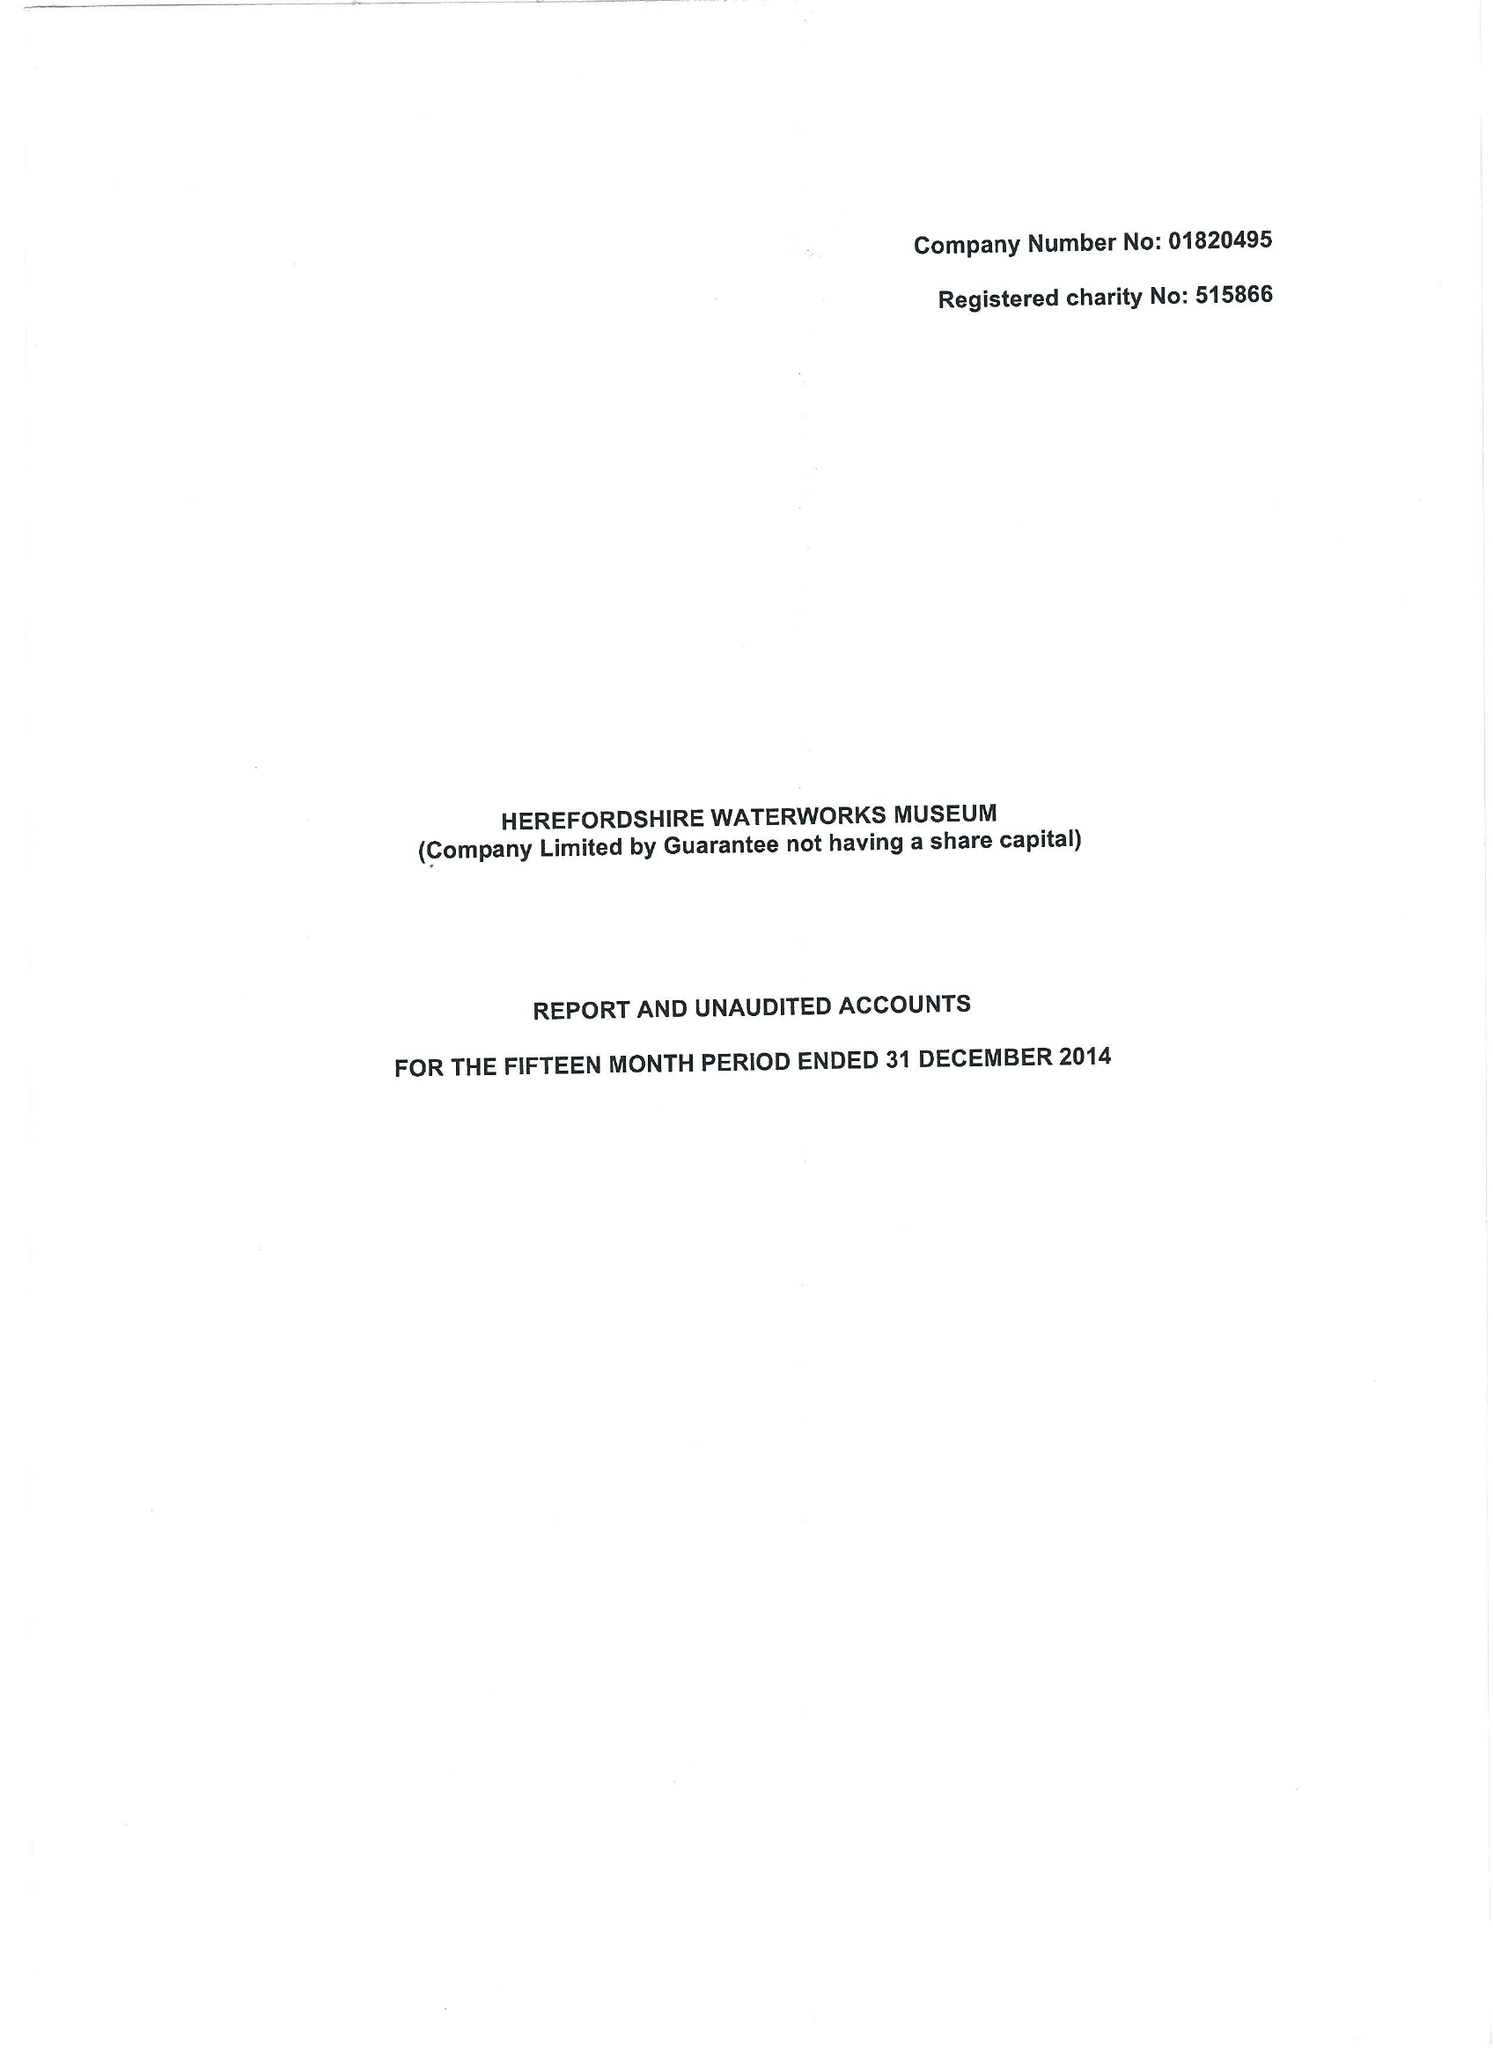What is the value for the charity_name?
Answer the question using a single word or phrase. Waterworks Museum - Hereford 